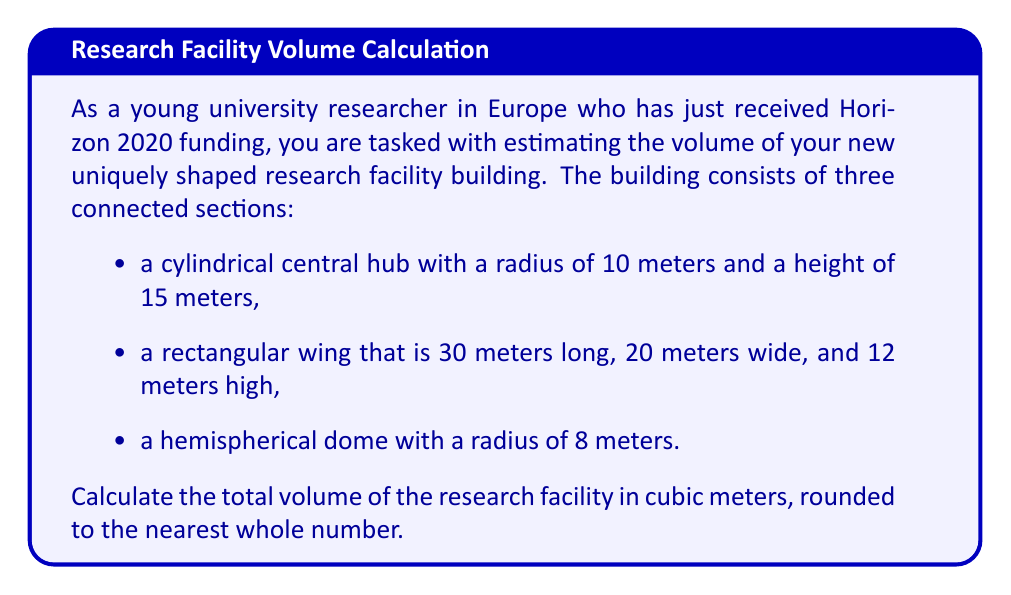Can you solve this math problem? To solve this problem, we need to calculate the volume of each section separately and then sum them up. Let's break it down step by step:

1. Cylindrical central hub:
   The volume of a cylinder is given by the formula $V = \pi r^2 h$
   $$V_{cylinder} = \pi \cdot 10^2 \cdot 15 = 1500\pi \approx 4712.39 \text{ m}^3$$

2. Rectangular wing:
   The volume of a rectangular prism is given by the formula $V = l \cdot w \cdot h$
   $$V_{rectangle} = 30 \cdot 20 \cdot 12 = 7200 \text{ m}^3$$

3. Hemispherical dome:
   The volume of a hemisphere is given by the formula $V = \frac{2}{3}\pi r^3$
   $$V_{hemisphere} = \frac{2}{3}\pi \cdot 8^3 = \frac{1024\pi}{3} \approx 1072.35 \text{ m}^3$$

Now, we sum up the volumes of all three sections:

$$V_{total} = V_{cylinder} + V_{rectangle} + V_{hemisphere}$$
$$V_{total} = 4712.39 + 7200 + 1072.35 = 12984.74 \text{ m}^3$$

Rounding to the nearest whole number:

$$V_{total} \approx 12985 \text{ m}^3$$

[asy]
import three;

size(200);
currentprojection=perspective(6,3,2);

// Cylinder
draw(cylinder((0,0,0),10,15),opacity(0.7));

// Rectangular wing
draw(box((10,0,0),(40,20,12)),opacity(0.7));

// Hemispherical dome
draw(shift(0,0,15)*scale3(8)*unitsphere,opacity(0.7));

// Labels
label("Cylinder", (5,5,7.5));
label("Rectangle", (25,10,6));
label("Hemisphere", (0,0,23));
[/asy]
Answer: The total volume of the research facility building is approximately 12985 cubic meters. 